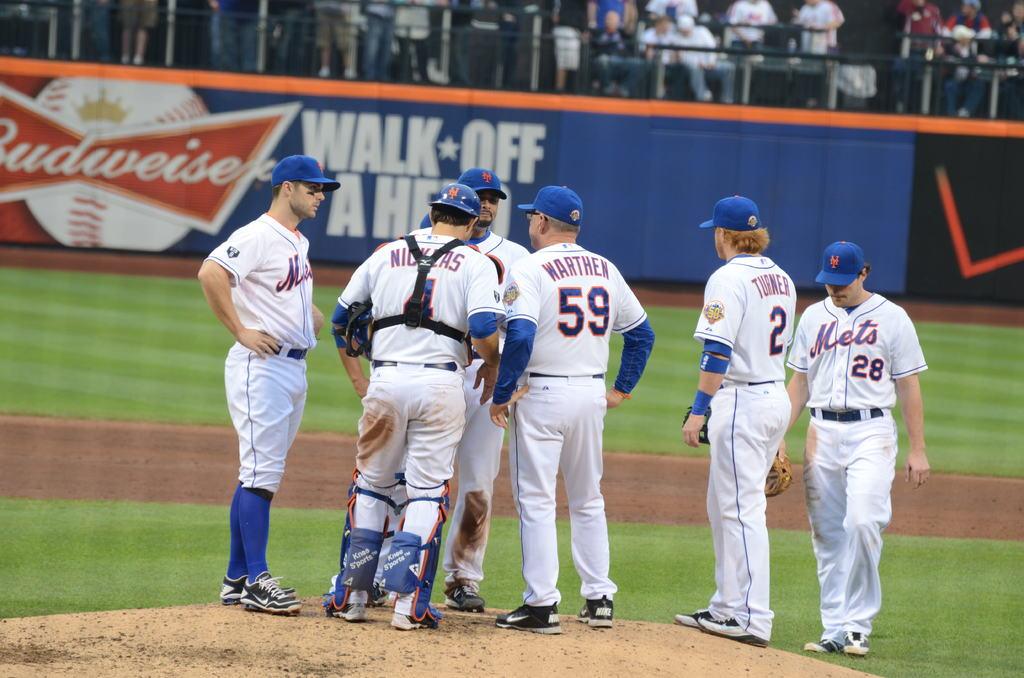What is the name of the beer on fence?
Your response must be concise. Budweiser. What is the man on the far rights number?
Make the answer very short. 28. 